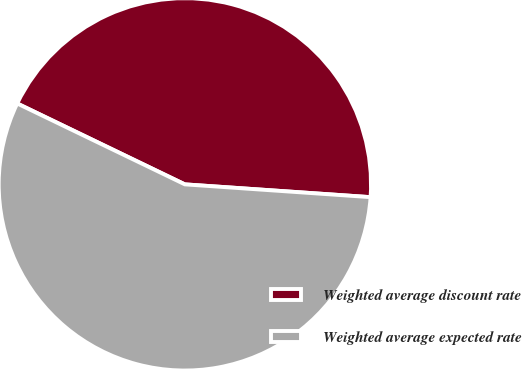Convert chart to OTSL. <chart><loc_0><loc_0><loc_500><loc_500><pie_chart><fcel>Weighted average discount rate<fcel>Weighted average expected rate<nl><fcel>43.94%<fcel>56.06%<nl></chart> 